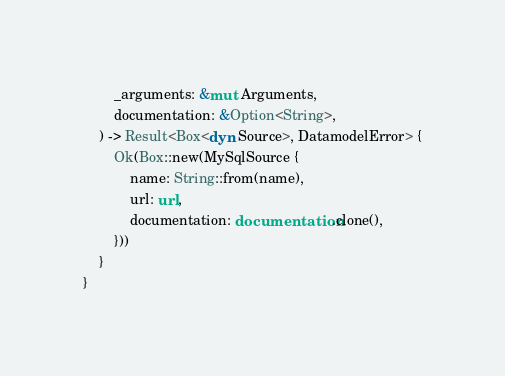<code> <loc_0><loc_0><loc_500><loc_500><_Rust_>        _arguments: &mut Arguments,
        documentation: &Option<String>,
    ) -> Result<Box<dyn Source>, DatamodelError> {
        Ok(Box::new(MySqlSource {
            name: String::from(name),
            url: url,
            documentation: documentation.clone(),
        }))
    }
}
</code> 